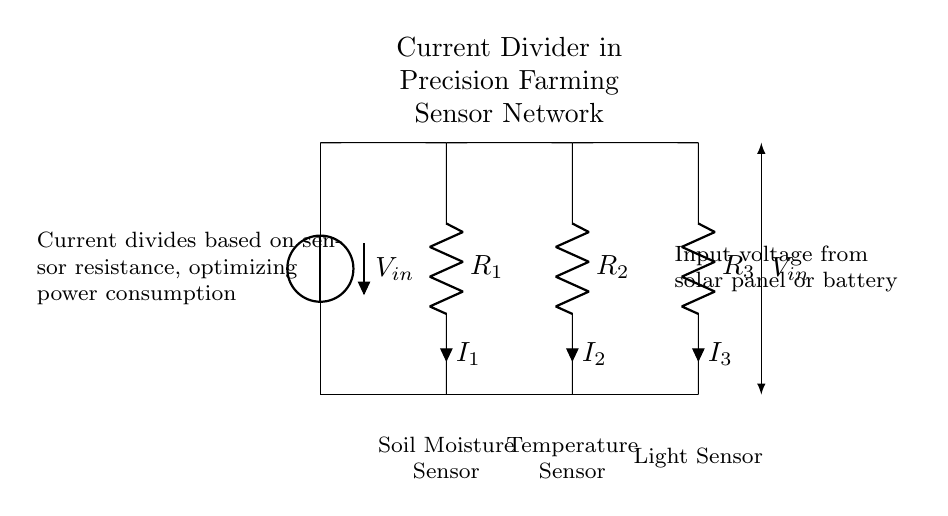What is the input voltage source in this circuit? The input voltage source is labeled as V_in, which is indicated as coming from a solar panel or battery. This information is provided in the circuit diagram.
Answer: V_in How many resistors are present in the current divider? There are three resistors in the circuit, labeled as R_1, R_2, and R_3. They are connected in parallel, as indicated by their placement in the diagram.
Answer: Three Which sensor is connected to R_2? The sensor connected to R_2 is the temperature sensor, as labeled in the circuit diagram. The labeling shows that the resistor corresponds to this specific sensor.
Answer: Temperature Sensor What does the current divider do for sensor networks in precision farming? The current divider optimizes power consumption by dividing current based on the resistance of each sensor, allowing for efficient operation of the entire network. This is visually conveyed in the diagram description.
Answer: Optimizes power consumption If the resistance R_1 is decreased, what effect will that have on I_1 compared to I_2 and I_3? If R_1 is decreased, according to the current divider principle, I_1 will increase while I_2 and I_3 will decrease. This is because current will take the path of least resistance, leading to a higher current flow through the lower resistance.
Answer: I_1 will increase What is the primary application of this current divider circuit in agriculture? The primary application is for sensor networks used in precision farming, enabling monitoring of various environmental parameters like moisture, temperature, and light to optimize agricultural practices. This is stated in the circuit description.
Answer: Sensor networks for precision farming 